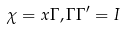<formula> <loc_0><loc_0><loc_500><loc_500>\chi = x \Gamma , \Gamma \Gamma ^ { \prime } = I</formula> 